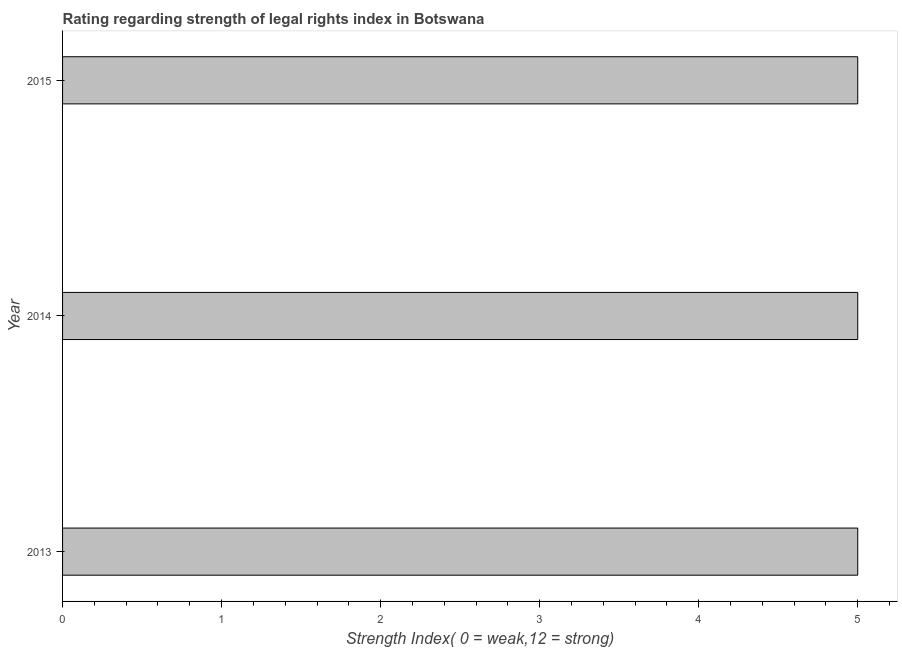Does the graph contain any zero values?
Your answer should be very brief. No. Does the graph contain grids?
Give a very brief answer. No. What is the title of the graph?
Offer a terse response. Rating regarding strength of legal rights index in Botswana. What is the label or title of the X-axis?
Ensure brevity in your answer.  Strength Index( 0 = weak,12 = strong). What is the label or title of the Y-axis?
Make the answer very short. Year. What is the sum of the strength of legal rights index?
Offer a terse response. 15. What is the difference between the strength of legal rights index in 2013 and 2014?
Provide a short and direct response. 0. What is the average strength of legal rights index per year?
Your answer should be compact. 5. In how many years, is the strength of legal rights index greater than 1.6 ?
Your answer should be very brief. 3. Is the strength of legal rights index in 2014 less than that in 2015?
Give a very brief answer. No. What is the difference between the highest and the second highest strength of legal rights index?
Give a very brief answer. 0. Is the sum of the strength of legal rights index in 2014 and 2015 greater than the maximum strength of legal rights index across all years?
Your response must be concise. Yes. What is the difference between the highest and the lowest strength of legal rights index?
Your answer should be compact. 0. Are all the bars in the graph horizontal?
Offer a terse response. Yes. What is the difference between two consecutive major ticks on the X-axis?
Ensure brevity in your answer.  1. Are the values on the major ticks of X-axis written in scientific E-notation?
Provide a short and direct response. No. What is the Strength Index( 0 = weak,12 = strong) of 2013?
Your answer should be compact. 5. What is the difference between the Strength Index( 0 = weak,12 = strong) in 2013 and 2014?
Your response must be concise. 0. What is the difference between the Strength Index( 0 = weak,12 = strong) in 2013 and 2015?
Provide a short and direct response. 0. What is the ratio of the Strength Index( 0 = weak,12 = strong) in 2013 to that in 2014?
Keep it short and to the point. 1. What is the ratio of the Strength Index( 0 = weak,12 = strong) in 2014 to that in 2015?
Offer a very short reply. 1. 